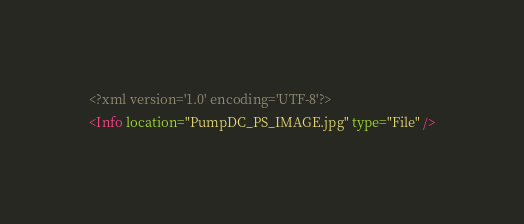Convert code to text. <code><loc_0><loc_0><loc_500><loc_500><_XML_><?xml version='1.0' encoding='UTF-8'?>
<Info location="PumpDC_PS_IMAGE.jpg" type="File" /></code> 